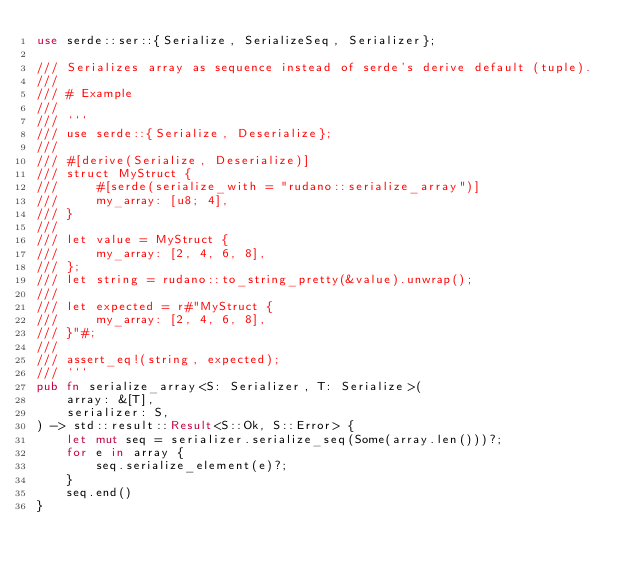Convert code to text. <code><loc_0><loc_0><loc_500><loc_500><_Rust_>use serde::ser::{Serialize, SerializeSeq, Serializer};

/// Serializes array as sequence instead of serde's derive default (tuple).
///
/// # Example
///
/// ```
/// use serde::{Serialize, Deserialize};
///
/// #[derive(Serialize, Deserialize)]
/// struct MyStruct {
///     #[serde(serialize_with = "rudano::serialize_array")]
///     my_array: [u8; 4],
/// }
///
/// let value = MyStruct {
///     my_array: [2, 4, 6, 8],
/// };
/// let string = rudano::to_string_pretty(&value).unwrap();
///
/// let expected = r#"MyStruct {
///     my_array: [2, 4, 6, 8],
/// }"#;
///
/// assert_eq!(string, expected);
/// ```
pub fn serialize_array<S: Serializer, T: Serialize>(
    array: &[T],
    serializer: S,
) -> std::result::Result<S::Ok, S::Error> {
    let mut seq = serializer.serialize_seq(Some(array.len()))?;
    for e in array {
        seq.serialize_element(e)?;
    }
    seq.end()
}
</code> 